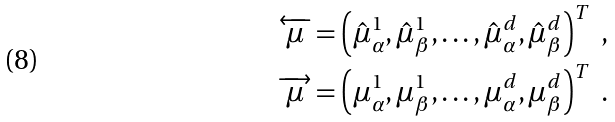Convert formula to latex. <formula><loc_0><loc_0><loc_500><loc_500>\overleftarrow { \mu } & = \left ( \hat { \mu } ^ { 1 } _ { \alpha } , \hat { \mu } ^ { 1 } _ { \beta } , \dots , \hat { \mu } ^ { d } _ { \alpha } , \hat { \mu } ^ { d } _ { \beta } \right ) ^ { T } \ , \\ \overrightarrow { \mu } & = \left ( \mu ^ { 1 } _ { \alpha } , \mu ^ { 1 } _ { \beta } , \dots , \mu ^ { d } _ { \alpha } , \mu ^ { d } _ { \beta } \right ) ^ { T } \ .</formula> 